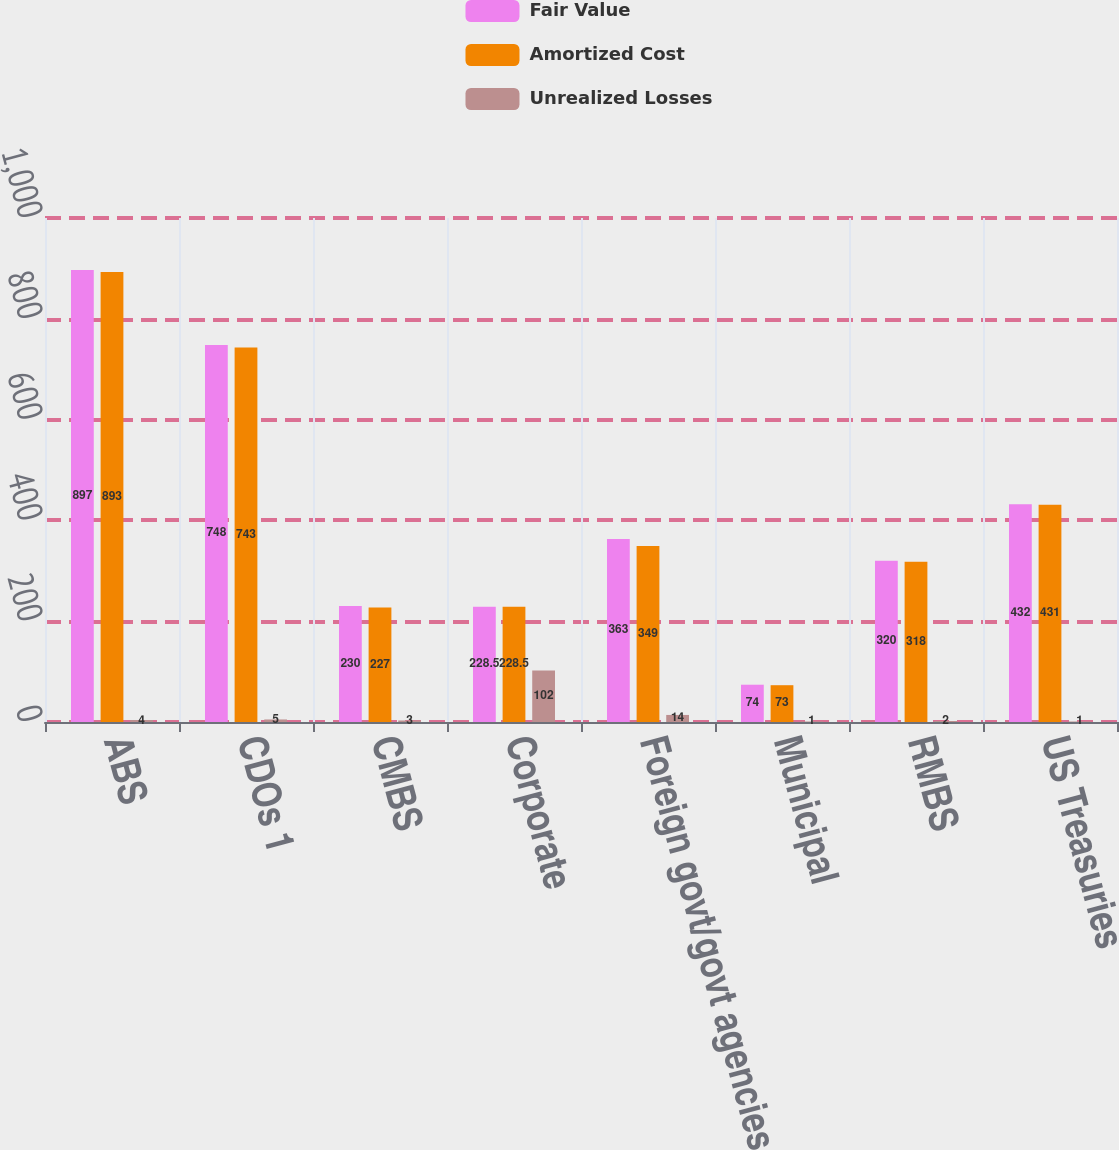Convert chart. <chart><loc_0><loc_0><loc_500><loc_500><stacked_bar_chart><ecel><fcel>ABS<fcel>CDOs 1<fcel>CMBS<fcel>Corporate<fcel>Foreign govt/govt agencies<fcel>Municipal<fcel>RMBS<fcel>US Treasuries<nl><fcel>Fair Value<fcel>897<fcel>748<fcel>230<fcel>228.5<fcel>363<fcel>74<fcel>320<fcel>432<nl><fcel>Amortized Cost<fcel>893<fcel>743<fcel>227<fcel>228.5<fcel>349<fcel>73<fcel>318<fcel>431<nl><fcel>Unrealized Losses<fcel>4<fcel>5<fcel>3<fcel>102<fcel>14<fcel>1<fcel>2<fcel>1<nl></chart> 